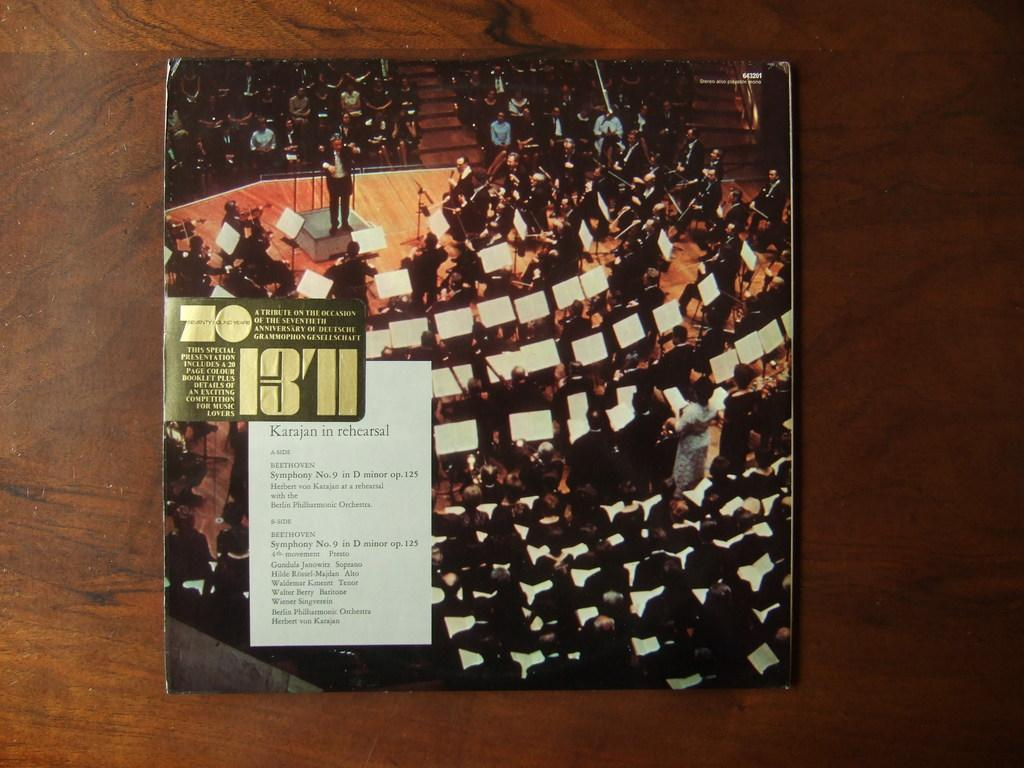What is the main subject of the image? The main subject of the image is a music album cover photo. Where is the album cover photo located in the image? The album cover photo is on a wooden table. What can be seen in the album cover photo? The cover photo features a group of people playing musical instruments. What type of division is depicted in the image? There is no division depicted in the image; it features a group of people playing musical instruments on an album cover photo. What time of day is shown in the image? The time of day cannot be determined from the image, as it only features a still photo of a group of people playing musical instruments. 